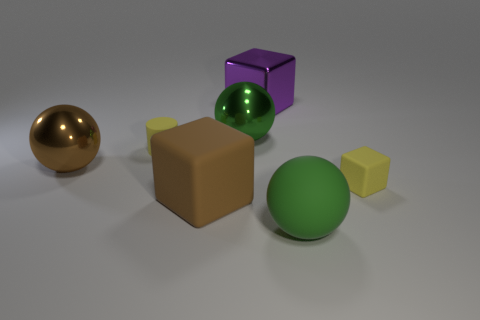Add 3 large gray matte balls. How many objects exist? 10 Subtract all green shiny spheres. How many spheres are left? 2 Subtract all red cylinders. How many green balls are left? 2 Subtract 1 cylinders. How many cylinders are left? 0 Subtract all brown spheres. How many spheres are left? 2 Add 3 green matte spheres. How many green matte spheres are left? 4 Add 3 large green metallic objects. How many large green metallic objects exist? 4 Subtract 1 yellow cylinders. How many objects are left? 6 Subtract all cubes. How many objects are left? 4 Subtract all brown cylinders. Subtract all gray blocks. How many cylinders are left? 1 